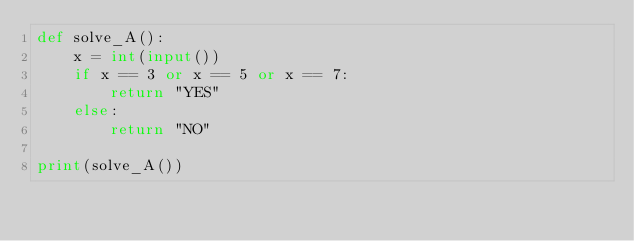Convert code to text. <code><loc_0><loc_0><loc_500><loc_500><_Python_>def solve_A():
    x = int(input())
    if x == 3 or x == 5 or x == 7:
        return "YES"
    else:
        return "NO"

print(solve_A())</code> 